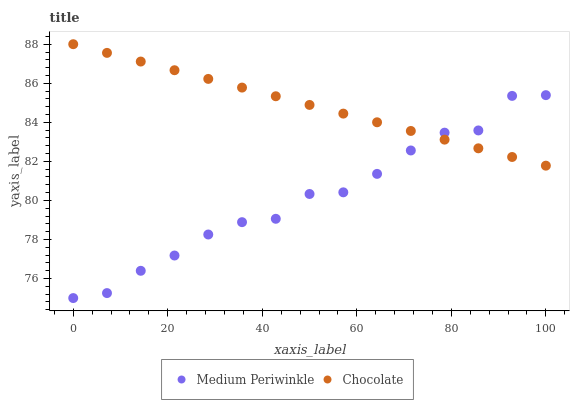Does Medium Periwinkle have the minimum area under the curve?
Answer yes or no. Yes. Does Chocolate have the maximum area under the curve?
Answer yes or no. Yes. Does Chocolate have the minimum area under the curve?
Answer yes or no. No. Is Chocolate the smoothest?
Answer yes or no. Yes. Is Medium Periwinkle the roughest?
Answer yes or no. Yes. Is Chocolate the roughest?
Answer yes or no. No. Does Medium Periwinkle have the lowest value?
Answer yes or no. Yes. Does Chocolate have the lowest value?
Answer yes or no. No. Does Chocolate have the highest value?
Answer yes or no. Yes. Does Chocolate intersect Medium Periwinkle?
Answer yes or no. Yes. Is Chocolate less than Medium Periwinkle?
Answer yes or no. No. Is Chocolate greater than Medium Periwinkle?
Answer yes or no. No. 